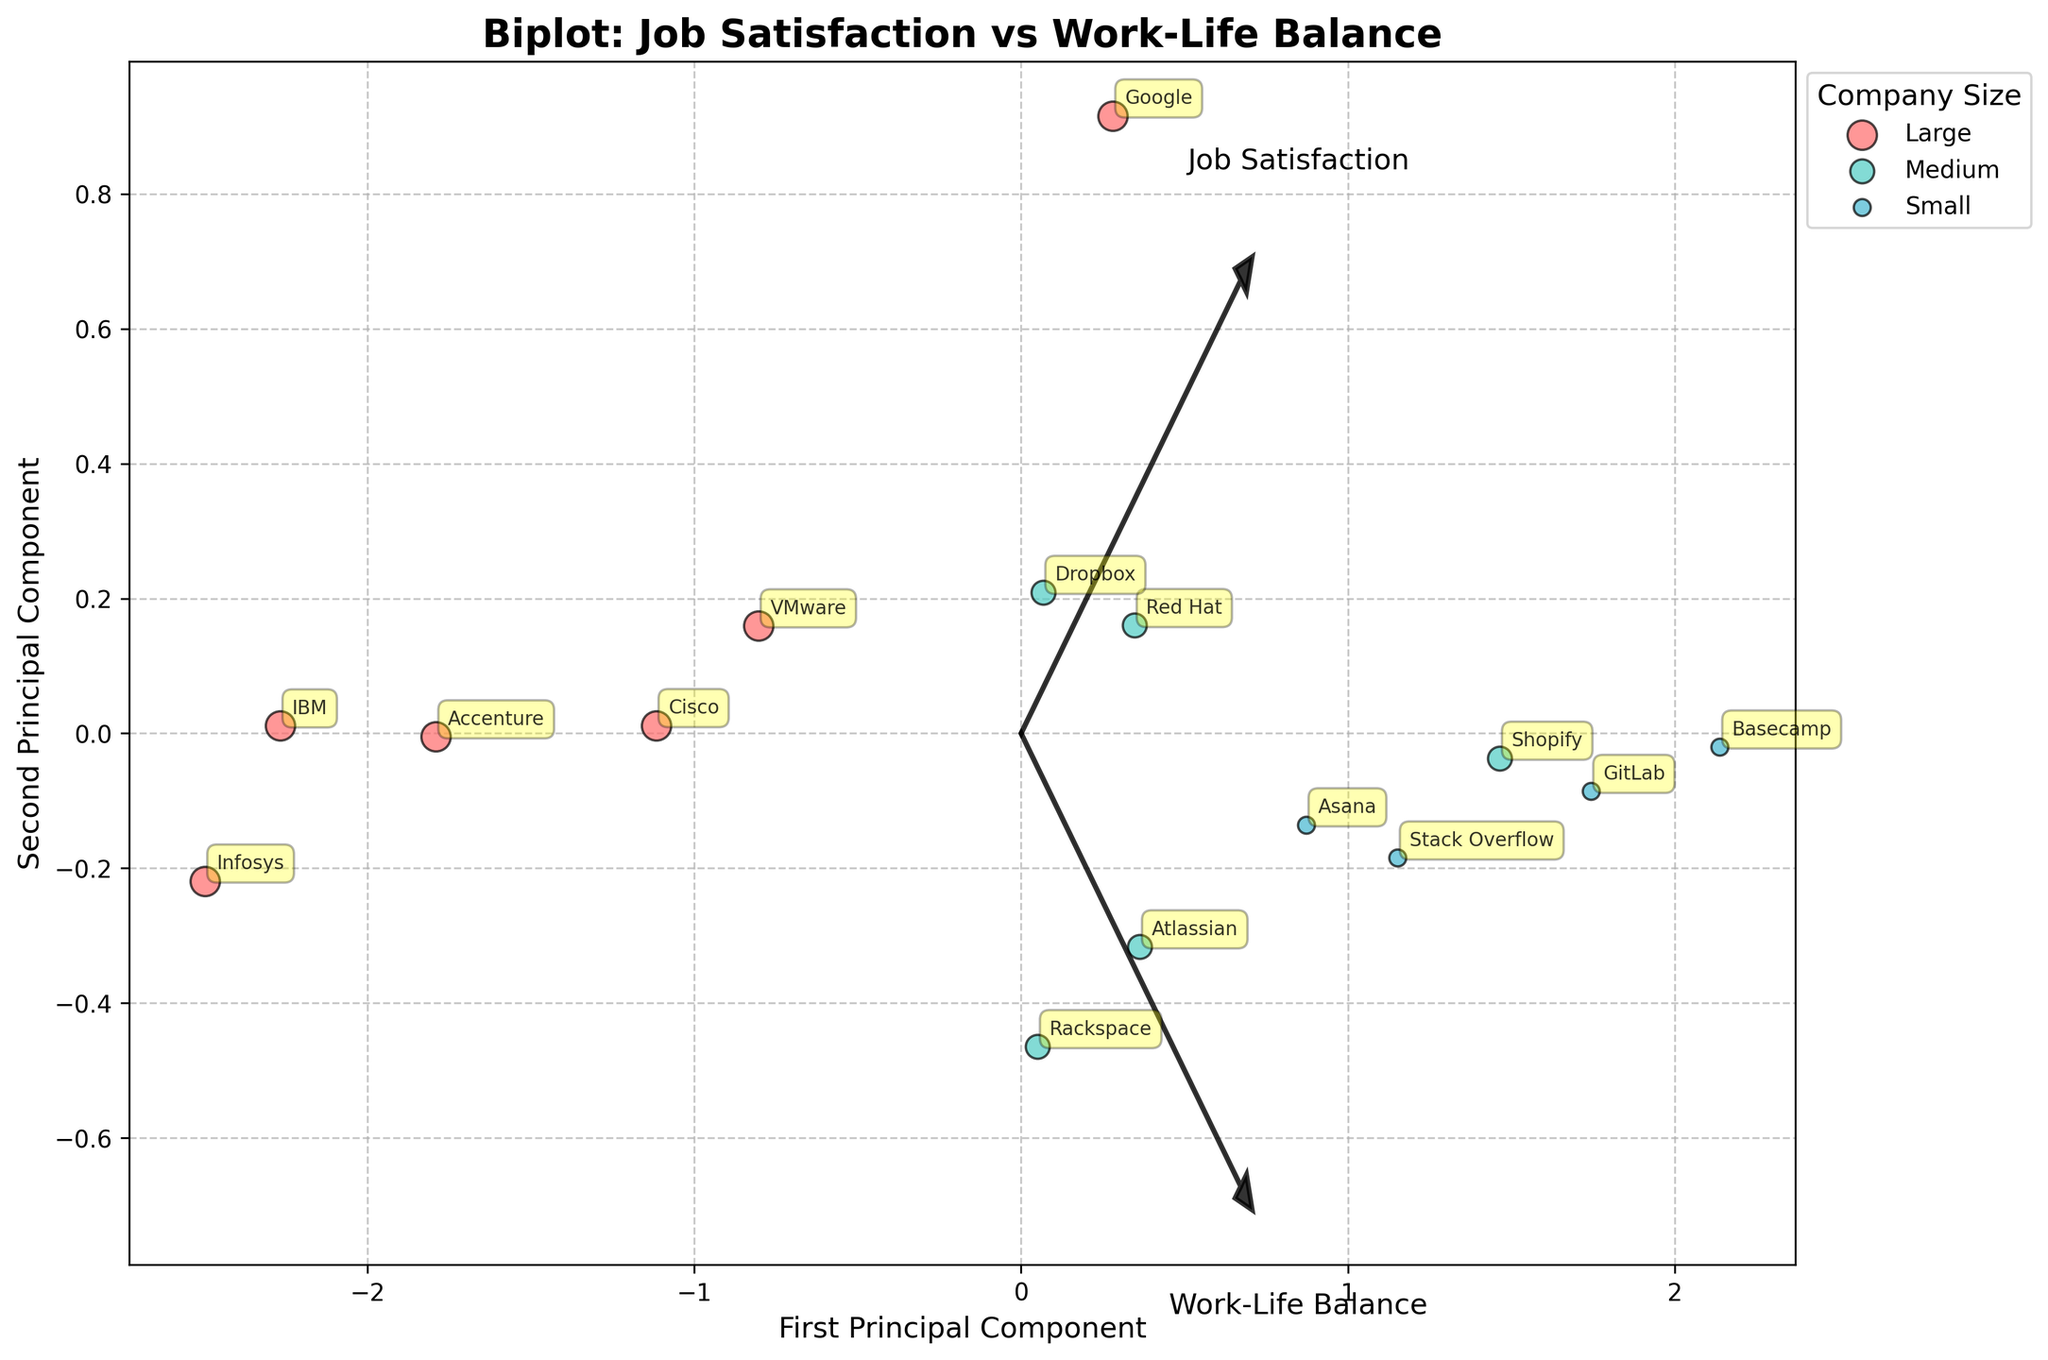What is the title of the plot? The title of the plot is written at the top and in bold. It reads "Biplot: Job Satisfaction vs Work-Life Balance".
Answer: Biplot: Job Satisfaction vs Work-Life Balance How many companies are represented in the plot? Each company is annotated with its name on the plot, and we can count these annotations to find the total number of companies represented.
Answer: 15 Which company is represented with the highest Job Satisfaction and Work-Life Balance? By observing the plot, look for the data point that is farthest in the direction of the vectors for Job Satisfaction and Work-Life Balance. The example shows that this company is annotated and located farther away along both vectors.
Answer: Basecamp Which company has the lowest Job Satisfaction? Job Satisfaction vector points horizontally; observe the data points' positions along this axis, focusing on the leftmost side. The company in this position is annotated.
Answer: Infosys Are there more large-size or medium-size companies in the plot? The legend indicates sizes by color. Count the number of data points marked with the respective sizes/colors. Compare the counts of each size group.
Answer: Large Which company has a better Work-Life Balance, Asana or Dropbox? Work-Life Balance is represented by one of the vectors. Compare the positions of Asana and Dropbox along this vector. The company farther along this vector has a better work-life balance.
Answer: Asana What is the relationship between company size and their clustering in terms of Job Satisfaction and Work-Life Balance? Observe the clustering and dispersion of large, medium, and small companies. Note general patterns, such as if a certain size tends to cluster in regions associated with specific satisfaction and balance values.
Answer: Medium and small companies tend to cluster with higher satisfaction and balance Is there any remote company on the plot? If yes, how many? Look at the annotations for company names and check their respective locations for "Remote". Count the occurrences.
Answer: Yes, 2 Which region has the most companies plotted, Remote or San Francisco? Check the annotations against the list provided in the data and count the number of companies based in 'Remote' and 'San Francisco'. Compare these counts.
Answer: San Francisco Which vector direction suggests a greater improvement in both Job Satisfaction and Work-Life Balance? Look at the orientation of both vectors (arrows). The direction that extends further in the positive axes for both dimensions indicates greater simultaneous improvement.
Answer: Upper right 